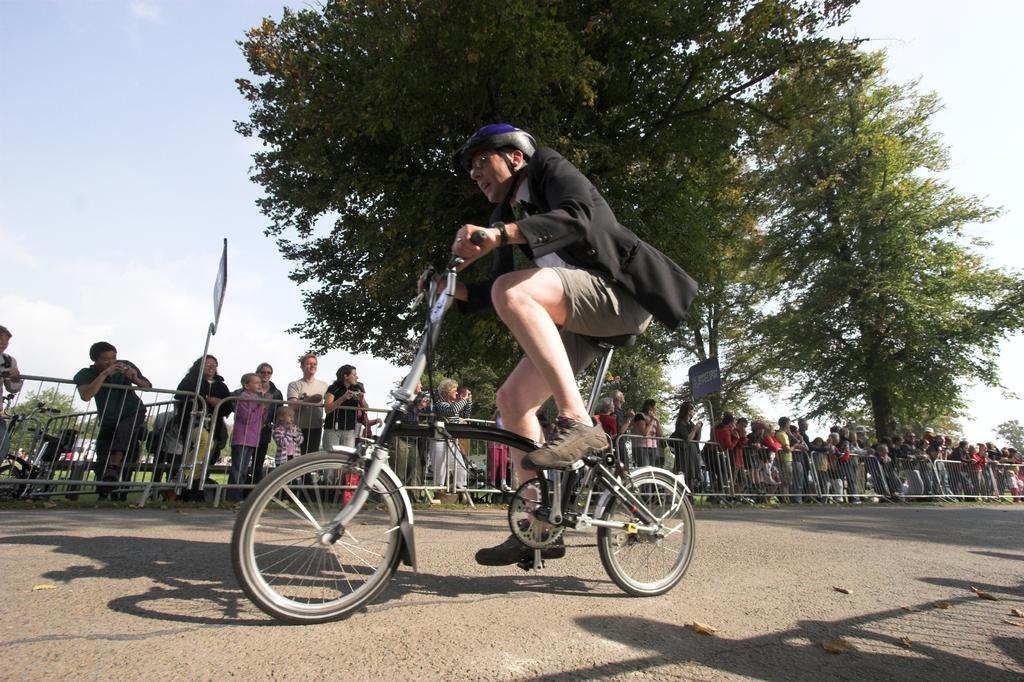Can you describe this image briefly? In the picture we can see a man riding a small bicycle, he is wearing a black color blazer and a helmet and beside him we can see a railing and behind it, we can see many people are standing and watching him and behind them we can see trees and sky. 